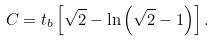<formula> <loc_0><loc_0><loc_500><loc_500>C = t _ { b } \left [ \sqrt { 2 } - \ln \left ( \sqrt { 2 } - 1 \right ) \right ] .</formula> 